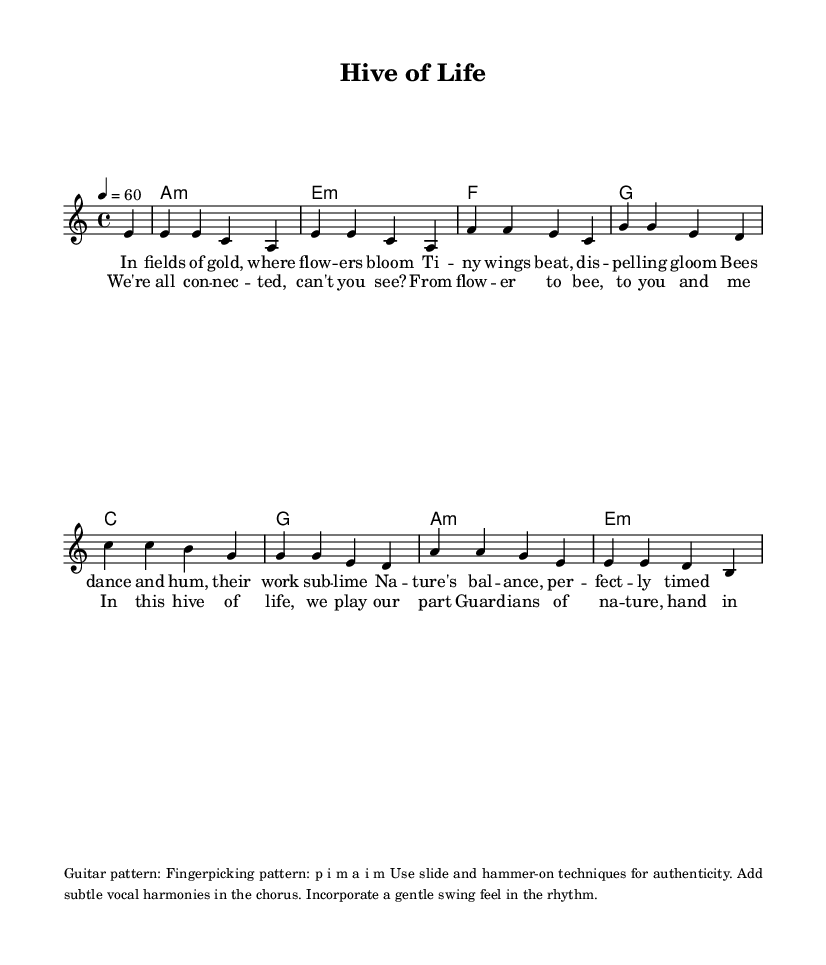What is the key signature of this music? The key signature is A minor, which has no sharps or flats and is indicated at the beginning of the score.
Answer: A minor What is the time signature of this music? The time signature is 4/4, which is shown at the beginning and means there are four beats in each measure, with the quarter note receiving one beat.
Answer: 4/4 What is the tempo marking for this piece? The tempo marking is a quarter note equals sixty beats per minute, indicated by the tempo directive at the start.
Answer: 60 How many measures are in the verse section? The verse section has four measures, which can be counted from the melody section where it begins and ends.
Answer: 4 What instrument is primarily indicated for the lead part in the score? The lead part is indicated for a voice, as shown in the staff designation for "lead".
Answer: Voice Why is the piece classified as a blues ballad? The piece is classified as a blues ballad due to its lyrical structure that emphasizes storytelling, the emotional quality of the melody, and themes that celebrate nature and human interconnectedness, which are characteristic of the blues genre.
Answer: Blues ballad Which guitar pattern is specified for this piece? The specified guitar pattern is a fingerpicking pattern described in the markup section, detailing the right-hand finger usage in the playing technique.
Answer: Fingerpicking pattern 